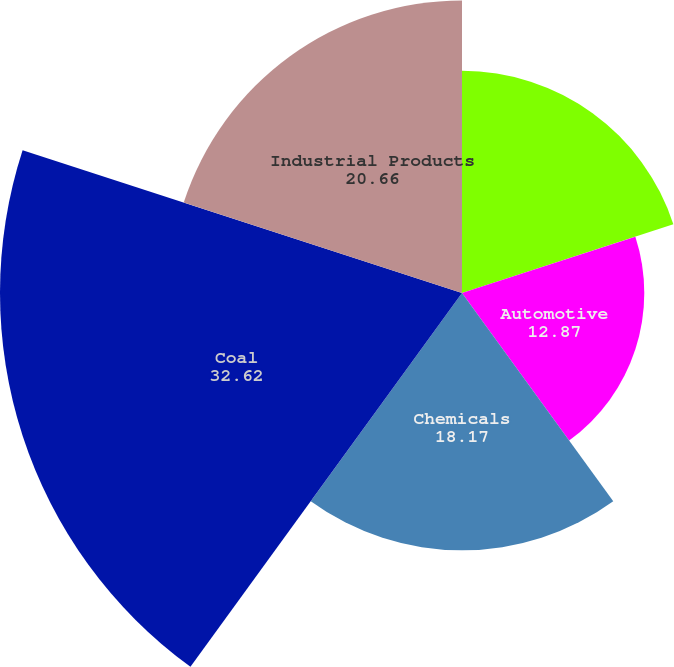<chart> <loc_0><loc_0><loc_500><loc_500><pie_chart><fcel>Agricultural<fcel>Automotive<fcel>Chemicals<fcel>Coal<fcel>Industrial Products<nl><fcel>15.69%<fcel>12.87%<fcel>18.17%<fcel>32.62%<fcel>20.66%<nl></chart> 